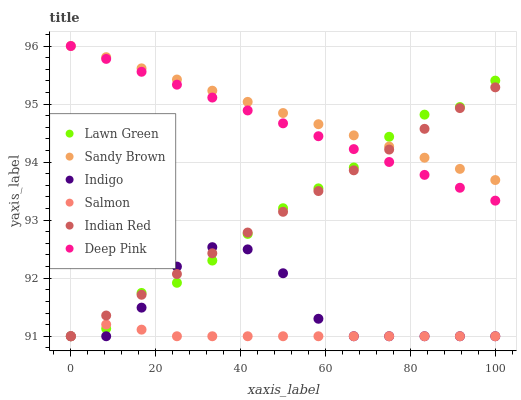Does Salmon have the minimum area under the curve?
Answer yes or no. Yes. Does Sandy Brown have the maximum area under the curve?
Answer yes or no. Yes. Does Deep Pink have the minimum area under the curve?
Answer yes or no. No. Does Deep Pink have the maximum area under the curve?
Answer yes or no. No. Is Sandy Brown the smoothest?
Answer yes or no. Yes. Is Indigo the roughest?
Answer yes or no. Yes. Is Deep Pink the smoothest?
Answer yes or no. No. Is Deep Pink the roughest?
Answer yes or no. No. Does Lawn Green have the lowest value?
Answer yes or no. Yes. Does Deep Pink have the lowest value?
Answer yes or no. No. Does Sandy Brown have the highest value?
Answer yes or no. Yes. Does Indigo have the highest value?
Answer yes or no. No. Is Salmon less than Deep Pink?
Answer yes or no. Yes. Is Deep Pink greater than Indigo?
Answer yes or no. Yes. Does Indian Red intersect Salmon?
Answer yes or no. Yes. Is Indian Red less than Salmon?
Answer yes or no. No. Is Indian Red greater than Salmon?
Answer yes or no. No. Does Salmon intersect Deep Pink?
Answer yes or no. No. 